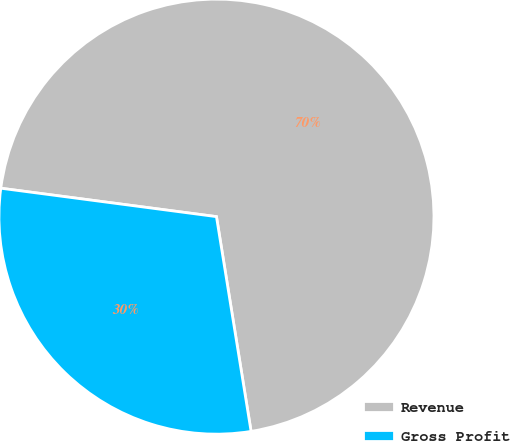Convert chart to OTSL. <chart><loc_0><loc_0><loc_500><loc_500><pie_chart><fcel>Revenue<fcel>Gross Profit<nl><fcel>70.37%<fcel>29.63%<nl></chart> 